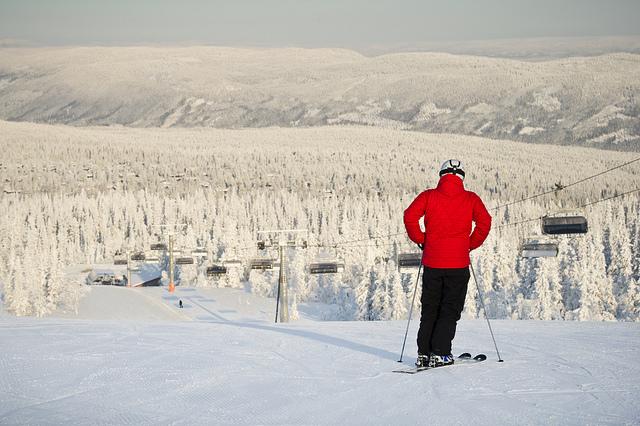Is this man in the red jacket scared?
Keep it brief. No. What kind of weather does this area have?
Give a very brief answer. Snowy. What brings people up to the top of the slope?
Write a very short answer. Skiing. 